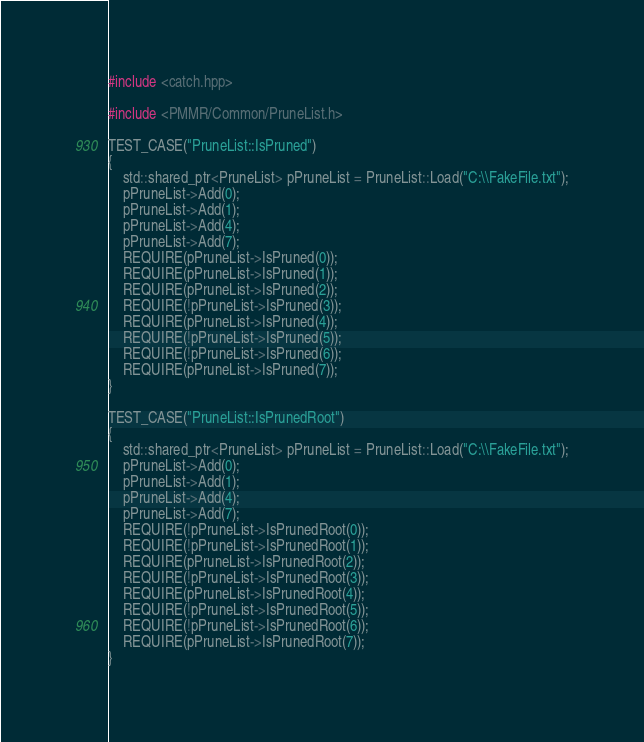<code> <loc_0><loc_0><loc_500><loc_500><_C++_>#include <catch.hpp>

#include <PMMR/Common/PruneList.h>

TEST_CASE("PruneList::IsPruned")
{
	std::shared_ptr<PruneList> pPruneList = PruneList::Load("C:\\FakeFile.txt");
	pPruneList->Add(0);
	pPruneList->Add(1);
	pPruneList->Add(4);
	pPruneList->Add(7);
	REQUIRE(pPruneList->IsPruned(0));
	REQUIRE(pPruneList->IsPruned(1));
	REQUIRE(pPruneList->IsPruned(2));
	REQUIRE(!pPruneList->IsPruned(3));
	REQUIRE(pPruneList->IsPruned(4));
	REQUIRE(!pPruneList->IsPruned(5));
	REQUIRE(!pPruneList->IsPruned(6));
	REQUIRE(pPruneList->IsPruned(7));
}

TEST_CASE("PruneList::IsPrunedRoot")
{
	std::shared_ptr<PruneList> pPruneList = PruneList::Load("C:\\FakeFile.txt");
	pPruneList->Add(0);
	pPruneList->Add(1);
	pPruneList->Add(4);
	pPruneList->Add(7);
	REQUIRE(!pPruneList->IsPrunedRoot(0));
	REQUIRE(!pPruneList->IsPrunedRoot(1));
	REQUIRE(pPruneList->IsPrunedRoot(2));
	REQUIRE(!pPruneList->IsPrunedRoot(3));
	REQUIRE(pPruneList->IsPrunedRoot(4));
	REQUIRE(!pPruneList->IsPrunedRoot(5));
	REQUIRE(!pPruneList->IsPrunedRoot(6));
	REQUIRE(pPruneList->IsPrunedRoot(7));
}</code> 